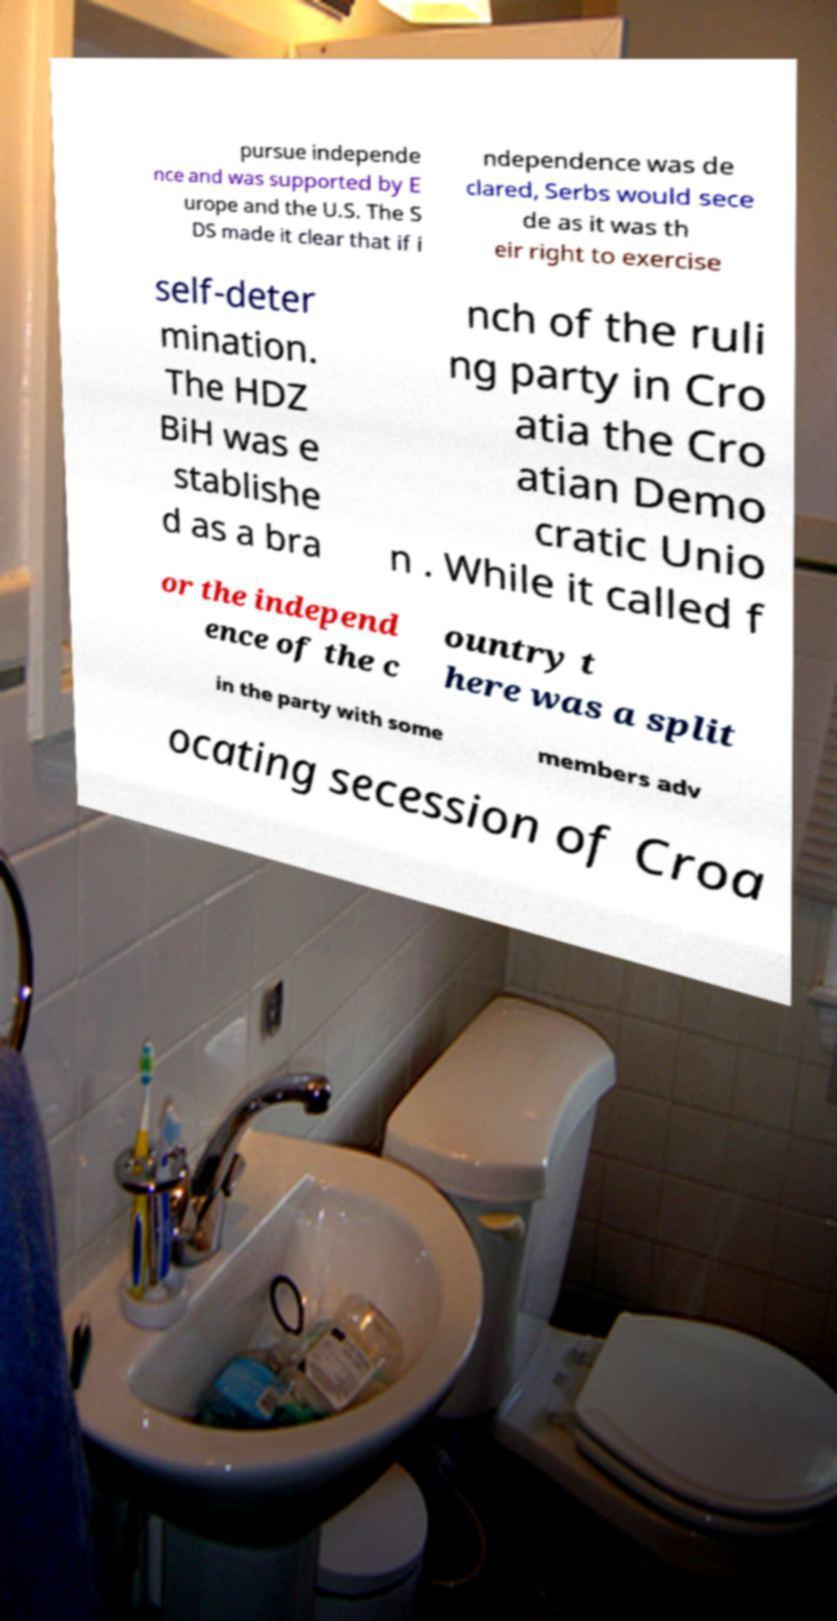There's text embedded in this image that I need extracted. Can you transcribe it verbatim? pursue independe nce and was supported by E urope and the U.S. The S DS made it clear that if i ndependence was de clared, Serbs would sece de as it was th eir right to exercise self-deter mination. The HDZ BiH was e stablishe d as a bra nch of the ruli ng party in Cro atia the Cro atian Demo cratic Unio n . While it called f or the independ ence of the c ountry t here was a split in the party with some members adv ocating secession of Croa 